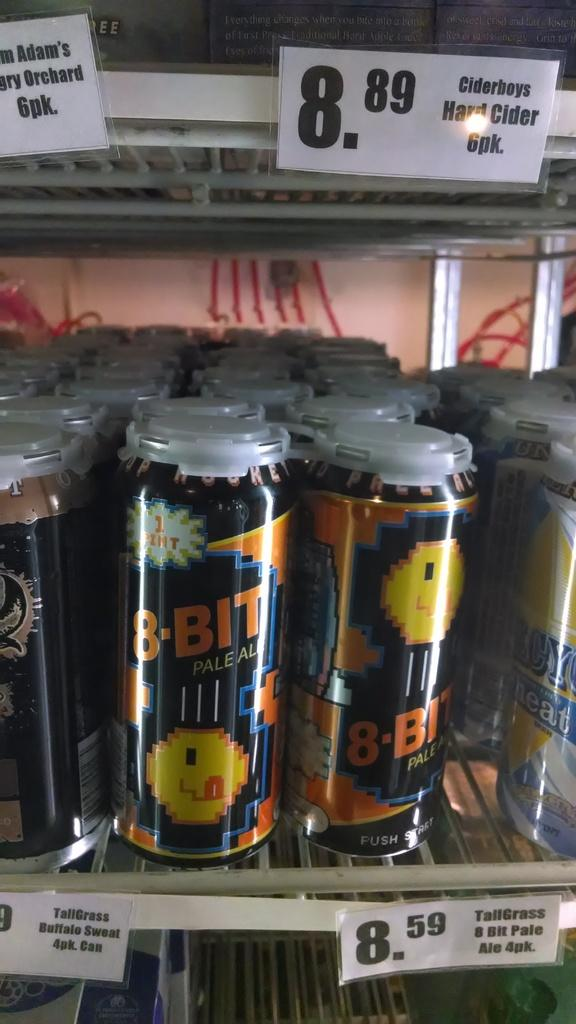<image>
Offer a succinct explanation of the picture presented. A display of cans of 8 bit pale ale. 